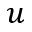<formula> <loc_0><loc_0><loc_500><loc_500>u</formula> 